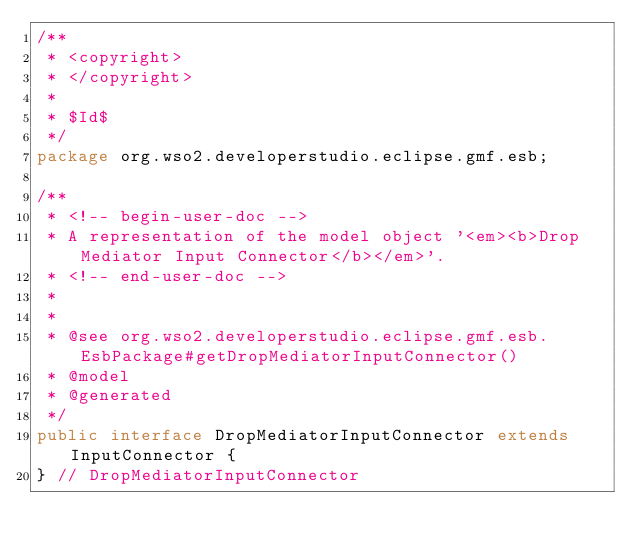Convert code to text. <code><loc_0><loc_0><loc_500><loc_500><_Java_>/**
 * <copyright>
 * </copyright>
 *
 * $Id$
 */
package org.wso2.developerstudio.eclipse.gmf.esb;

/**
 * <!-- begin-user-doc -->
 * A representation of the model object '<em><b>Drop Mediator Input Connector</b></em>'.
 * <!-- end-user-doc -->
 *
 *
 * @see org.wso2.developerstudio.eclipse.gmf.esb.EsbPackage#getDropMediatorInputConnector()
 * @model
 * @generated
 */
public interface DropMediatorInputConnector extends InputConnector {
} // DropMediatorInputConnector
</code> 